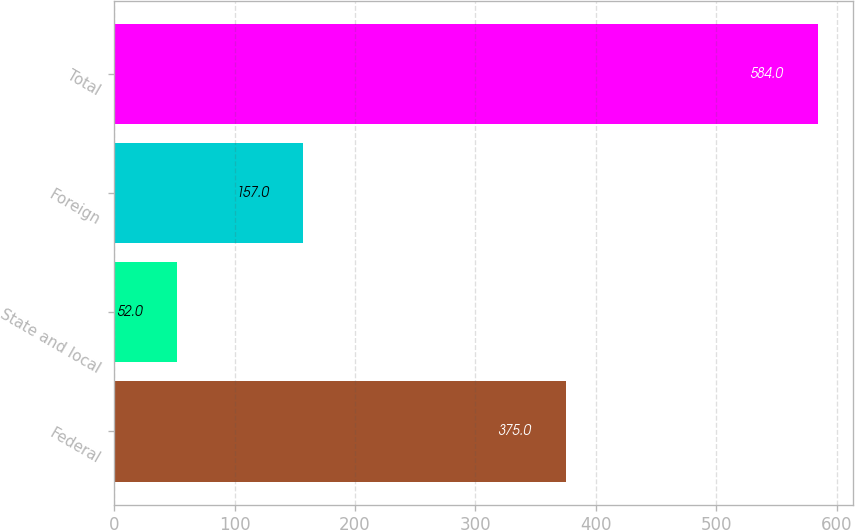Convert chart. <chart><loc_0><loc_0><loc_500><loc_500><bar_chart><fcel>Federal<fcel>State and local<fcel>Foreign<fcel>Total<nl><fcel>375<fcel>52<fcel>157<fcel>584<nl></chart> 